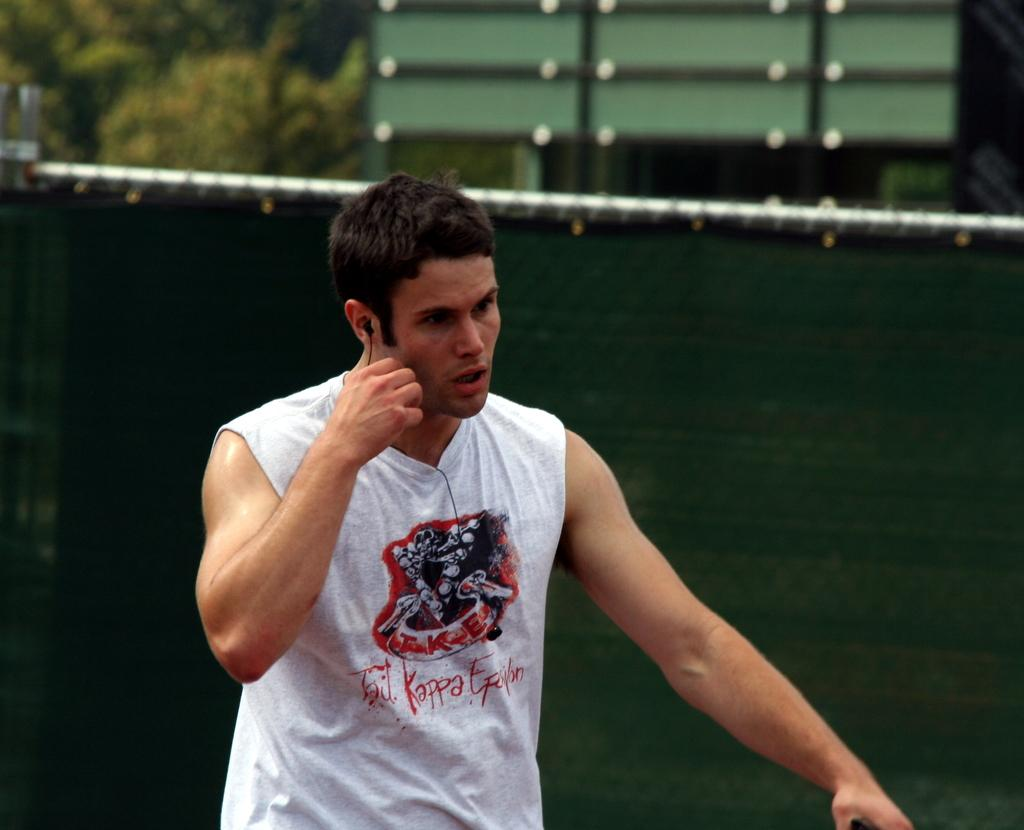What can be seen in the image? There is a person in the image. What is the person wearing? The person is wearing a white-colored dress. Can you describe the background of the image? The background of the image is blurry, and the background color is green. How many additions can be seen in the image? There are no additions present in the image. What type of bird is sitting on the person's shoulder in the image? There is no bird, specifically a wren, present in the image. 